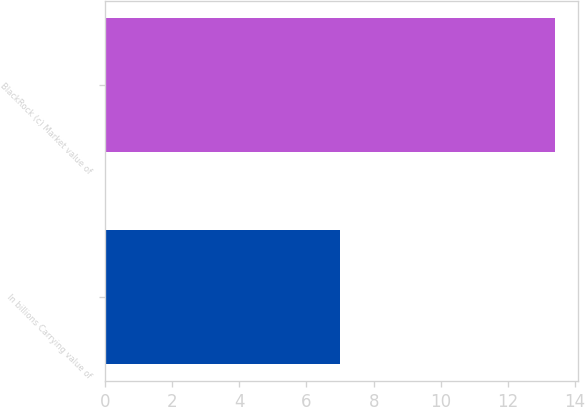Convert chart to OTSL. <chart><loc_0><loc_0><loc_500><loc_500><bar_chart><fcel>In billions Carrying value of<fcel>BlackRock (c) Market value of<nl><fcel>7<fcel>13.4<nl></chart> 